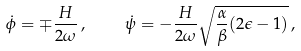Convert formula to latex. <formula><loc_0><loc_0><loc_500><loc_500>\dot { \phi } = \mp \frac { H } { 2 \omega } \, , \quad \dot { \psi } = - \frac { H } { 2 \omega } \sqrt { \frac { \alpha } { \beta } ( 2 \epsilon - 1 ) } \, ,</formula> 